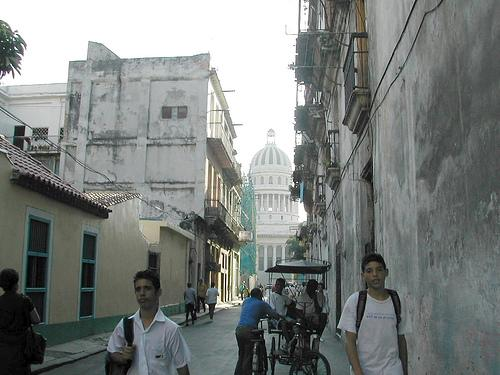Who is closest to the wall? boy 